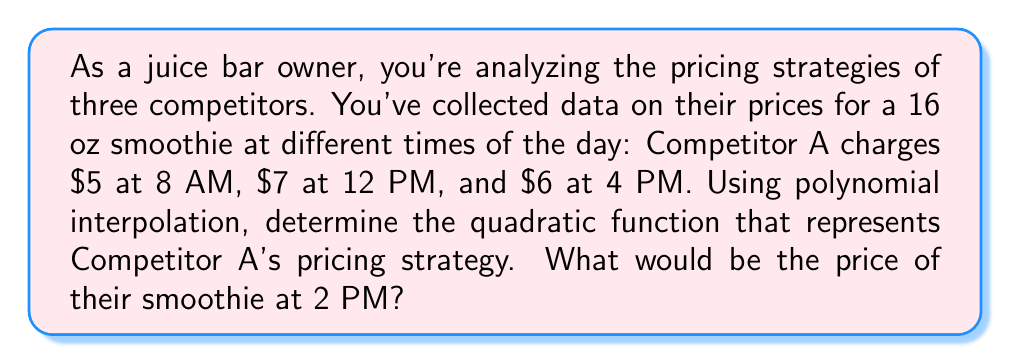Can you solve this math problem? Let's approach this step-by-step using polynomial interpolation:

1) We have three data points: (8, 5), (12, 7), and (16, 6), where the x-coordinate represents the hour (in 24-hour format) and the y-coordinate represents the price.

2) We're looking for a quadratic function of the form $f(x) = ax^2 + bx + c$.

3) Substituting our data points into this equation:

   $5 = 64a + 8b + c$
   $7 = 144a + 12b + c$
   $6 = 256a + 16b + c$

4) Subtracting the first equation from the second and third:

   $2 = 80a + 4b$
   $1 = 192a + 8b$

5) Multiplying the first equation by 2 and subtracting from the second:

   $32a = -1$
   $a = -\frac{1}{32}$

6) Substituting this back into $2 = 80a + 4b$:

   $2 = 80(-\frac{1}{32}) + 4b$
   $2 = -\frac{5}{2} + 4b$
   $\frac{9}{2} = 4b$
   $b = \frac{9}{8}$

7) Using these values in the original equation:

   $5 = 64(-\frac{1}{32}) + 8(\frac{9}{8}) + c$
   $5 = -2 + 9 + c$
   $c = -2$

8) Therefore, our quadratic function is:

   $f(x) = -\frac{1}{32}x^2 + \frac{9}{8}x - 2$

9) To find the price at 2 PM (14:00 in 24-hour format), we calculate:

   $f(14) = -\frac{1}{32}(14)^2 + \frac{9}{8}(14) - 2$
          $= -\frac{196}{32} + \frac{126}{8} - 2$
          $= -6.125 + 15.75 - 2$
          $= 7.625$
Answer: $7.63 